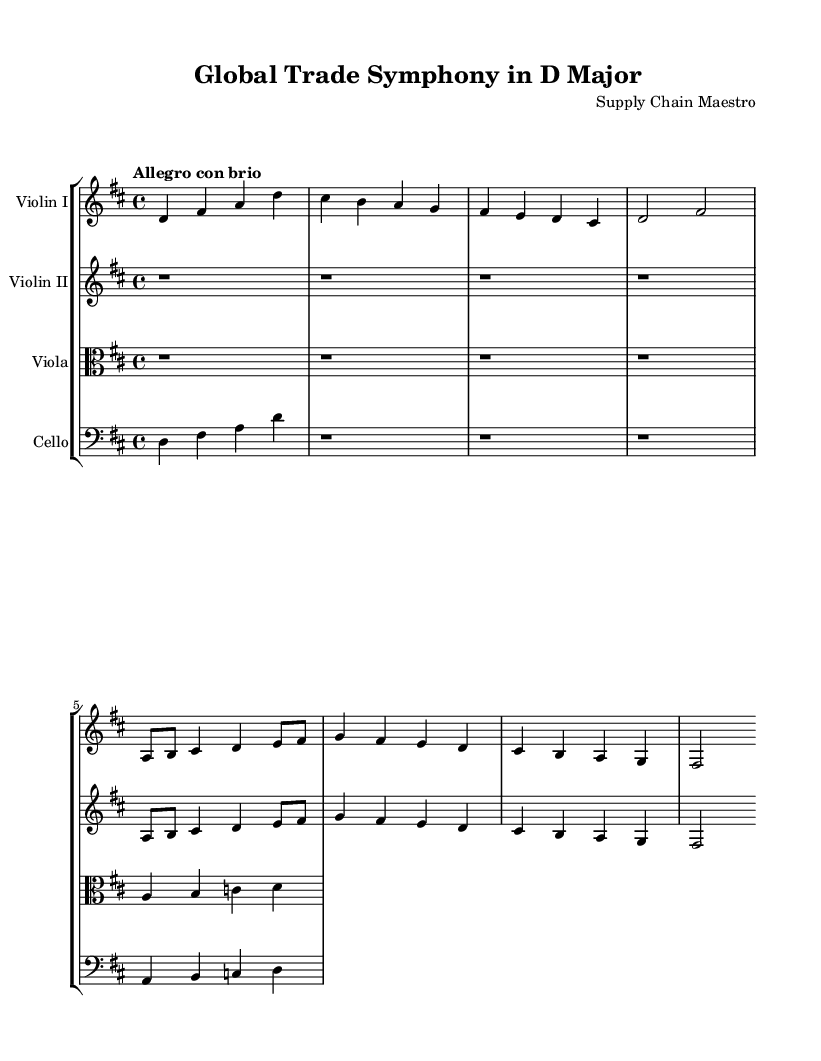What is the key signature of this music? The key signature is indicated in the beginning section of the sheet music, where the number of sharps or flats is shown. In this case, there are two sharps, which corresponds to the key of D major.
Answer: D major What is the time signature of this piece? The time signature appears at the beginning of the first staff, indicated as 4/4, which means there are four beats in a measure and a quarter note gets one beat.
Answer: 4/4 What is the tempo marking for this symphony? The tempo marking is located right after the time signature and states "Allegro con brio," which denotes a fast and lively pace.
Answer: Allegro con brio How many measures are present in the main theme? To find the number of measures in the main theme, we count visually from the start to the end of the section. The main theme has four measures in total.
Answer: Four What instruments are featured in this symphony? The instruments are listed at the beginning of each staff, and in this score, there are Violin I, Violin II, Viola, and Cello.
Answer: Violin I, Violin II, Viola, Cello How does the secondary theme differ from the main theme? An analysis of the sections shows that while the main theme is structured in a simpler melodic form, the secondary theme contains more rhythmic variety and uses shorter note durations, reflecting a contrasting character.
Answer: Rhythmic variety What is the resting beat for the Viola part? The resting beat is noted as "r" which stands for silence. Upon inspection, the Viola part has four resting beats before the musical line starts.
Answer: Four 